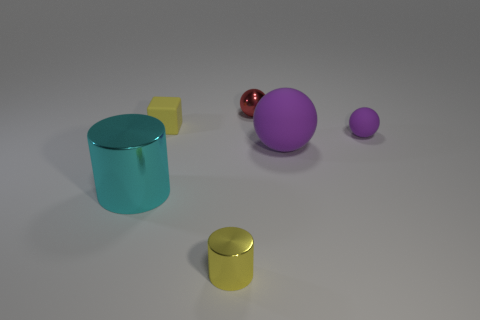Add 1 large matte balls. How many objects exist? 7 Subtract all cylinders. How many objects are left? 4 Subtract all large blue spheres. Subtract all big balls. How many objects are left? 5 Add 1 big cyan cylinders. How many big cyan cylinders are left? 2 Add 4 metallic balls. How many metallic balls exist? 5 Subtract 1 yellow cylinders. How many objects are left? 5 